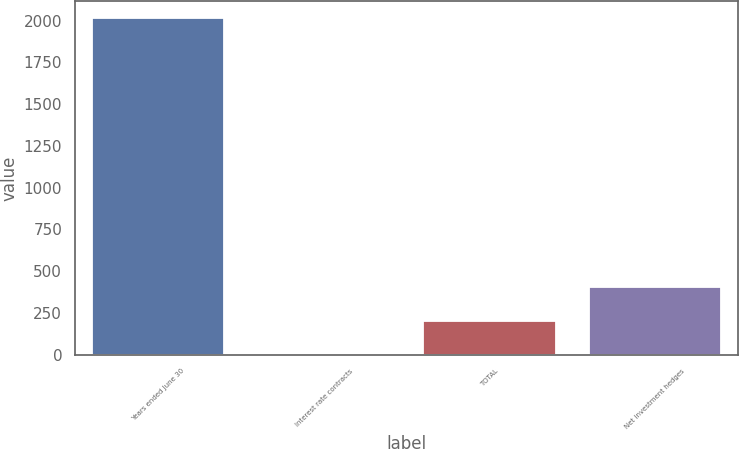Convert chart to OTSL. <chart><loc_0><loc_0><loc_500><loc_500><bar_chart><fcel>Years ended June 30<fcel>Interest rate contracts<fcel>TOTAL<fcel>Net investment hedges<nl><fcel>2016<fcel>2<fcel>203.4<fcel>404.8<nl></chart> 